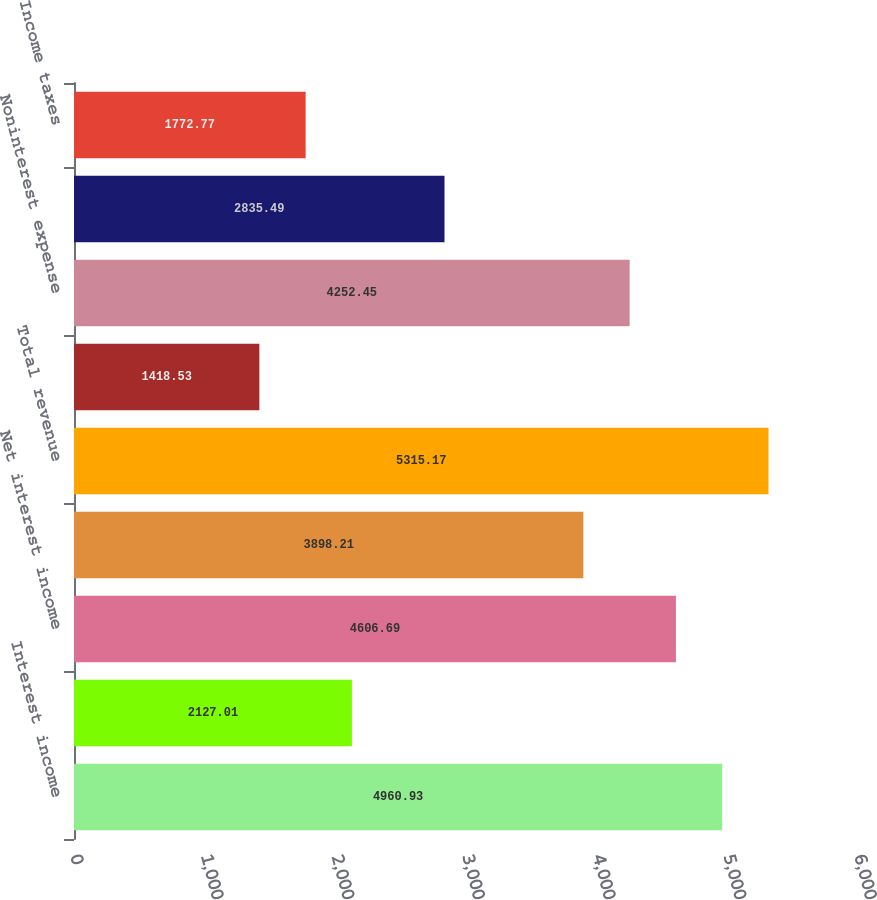Convert chart. <chart><loc_0><loc_0><loc_500><loc_500><bar_chart><fcel>Interest income<fcel>Interest expense<fcel>Net interest income<fcel>Noninterest income (a)<fcel>Total revenue<fcel>Provision for credit losses<fcel>Noninterest expense<fcel>Income from continuing<fcel>Income taxes<nl><fcel>4960.93<fcel>2127.01<fcel>4606.69<fcel>3898.21<fcel>5315.17<fcel>1418.53<fcel>4252.45<fcel>2835.49<fcel>1772.77<nl></chart> 